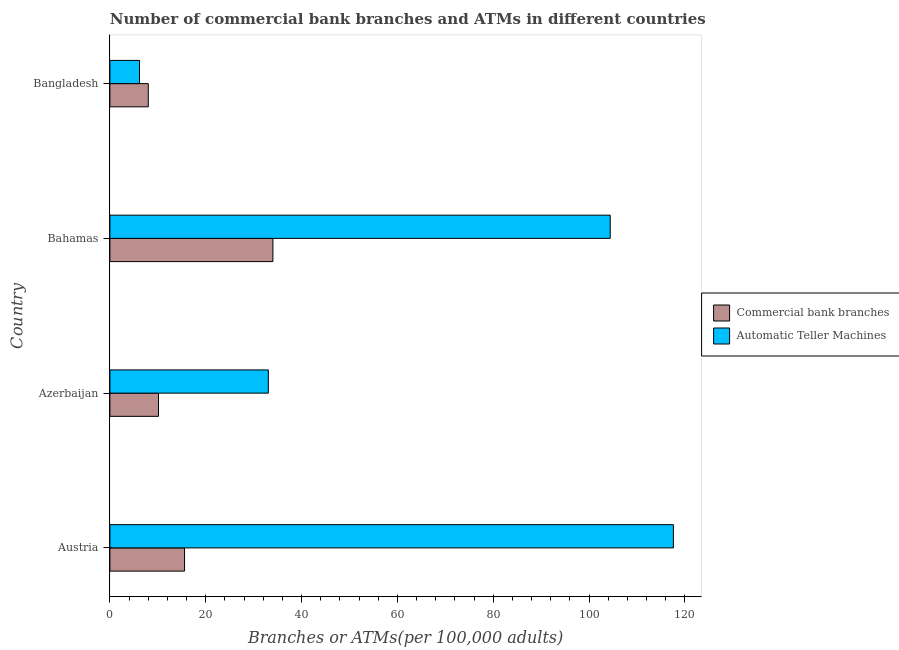How many groups of bars are there?
Offer a very short reply. 4. Are the number of bars per tick equal to the number of legend labels?
Your answer should be very brief. Yes. How many bars are there on the 4th tick from the top?
Keep it short and to the point. 2. How many bars are there on the 3rd tick from the bottom?
Offer a very short reply. 2. What is the label of the 4th group of bars from the top?
Give a very brief answer. Austria. In how many cases, is the number of bars for a given country not equal to the number of legend labels?
Your response must be concise. 0. What is the number of atms in Azerbaijan?
Provide a succinct answer. 33.06. Across all countries, what is the maximum number of commercal bank branches?
Ensure brevity in your answer.  34.02. Across all countries, what is the minimum number of atms?
Your answer should be very brief. 6.18. In which country was the number of atms maximum?
Provide a short and direct response. Austria. In which country was the number of atms minimum?
Your answer should be compact. Bangladesh. What is the total number of atms in the graph?
Your answer should be very brief. 261.26. What is the difference between the number of atms in Bahamas and that in Bangladesh?
Keep it short and to the point. 98.23. What is the difference between the number of commercal bank branches in Austria and the number of atms in Azerbaijan?
Offer a very short reply. -17.48. What is the average number of atms per country?
Your answer should be compact. 65.31. What is the difference between the number of commercal bank branches and number of atms in Bangladesh?
Make the answer very short. 1.83. In how many countries, is the number of atms greater than 4 ?
Provide a short and direct response. 4. What is the ratio of the number of atms in Austria to that in Bahamas?
Keep it short and to the point. 1.13. Is the number of commercal bank branches in Austria less than that in Bahamas?
Your answer should be compact. Yes. What is the difference between the highest and the second highest number of atms?
Your answer should be compact. 13.18. What is the difference between the highest and the lowest number of atms?
Offer a very short reply. 111.42. In how many countries, is the number of atms greater than the average number of atms taken over all countries?
Make the answer very short. 2. Is the sum of the number of atms in Azerbaijan and Bangladesh greater than the maximum number of commercal bank branches across all countries?
Your response must be concise. Yes. What does the 2nd bar from the top in Bangladesh represents?
Provide a short and direct response. Commercial bank branches. What does the 1st bar from the bottom in Austria represents?
Offer a very short reply. Commercial bank branches. Are all the bars in the graph horizontal?
Your response must be concise. Yes. Are the values on the major ticks of X-axis written in scientific E-notation?
Keep it short and to the point. No. Does the graph contain any zero values?
Give a very brief answer. No. Where does the legend appear in the graph?
Make the answer very short. Center right. How are the legend labels stacked?
Give a very brief answer. Vertical. What is the title of the graph?
Offer a very short reply. Number of commercial bank branches and ATMs in different countries. Does "Female labor force" appear as one of the legend labels in the graph?
Keep it short and to the point. No. What is the label or title of the X-axis?
Provide a succinct answer. Branches or ATMs(per 100,0 adults). What is the label or title of the Y-axis?
Your answer should be compact. Country. What is the Branches or ATMs(per 100,000 adults) in Commercial bank branches in Austria?
Provide a short and direct response. 15.58. What is the Branches or ATMs(per 100,000 adults) in Automatic Teller Machines in Austria?
Your answer should be very brief. 117.6. What is the Branches or ATMs(per 100,000 adults) in Commercial bank branches in Azerbaijan?
Provide a short and direct response. 10.14. What is the Branches or ATMs(per 100,000 adults) of Automatic Teller Machines in Azerbaijan?
Ensure brevity in your answer.  33.06. What is the Branches or ATMs(per 100,000 adults) of Commercial bank branches in Bahamas?
Your answer should be compact. 34.02. What is the Branches or ATMs(per 100,000 adults) of Automatic Teller Machines in Bahamas?
Offer a terse response. 104.42. What is the Branches or ATMs(per 100,000 adults) in Commercial bank branches in Bangladesh?
Offer a very short reply. 8.02. What is the Branches or ATMs(per 100,000 adults) in Automatic Teller Machines in Bangladesh?
Give a very brief answer. 6.18. Across all countries, what is the maximum Branches or ATMs(per 100,000 adults) of Commercial bank branches?
Keep it short and to the point. 34.02. Across all countries, what is the maximum Branches or ATMs(per 100,000 adults) in Automatic Teller Machines?
Make the answer very short. 117.6. Across all countries, what is the minimum Branches or ATMs(per 100,000 adults) in Commercial bank branches?
Give a very brief answer. 8.02. Across all countries, what is the minimum Branches or ATMs(per 100,000 adults) of Automatic Teller Machines?
Make the answer very short. 6.18. What is the total Branches or ATMs(per 100,000 adults) of Commercial bank branches in the graph?
Your answer should be compact. 67.76. What is the total Branches or ATMs(per 100,000 adults) in Automatic Teller Machines in the graph?
Your answer should be very brief. 261.26. What is the difference between the Branches or ATMs(per 100,000 adults) in Commercial bank branches in Austria and that in Azerbaijan?
Your answer should be very brief. 5.44. What is the difference between the Branches or ATMs(per 100,000 adults) in Automatic Teller Machines in Austria and that in Azerbaijan?
Your answer should be very brief. 84.53. What is the difference between the Branches or ATMs(per 100,000 adults) of Commercial bank branches in Austria and that in Bahamas?
Provide a short and direct response. -18.44. What is the difference between the Branches or ATMs(per 100,000 adults) in Automatic Teller Machines in Austria and that in Bahamas?
Ensure brevity in your answer.  13.18. What is the difference between the Branches or ATMs(per 100,000 adults) in Commercial bank branches in Austria and that in Bangladesh?
Make the answer very short. 7.57. What is the difference between the Branches or ATMs(per 100,000 adults) of Automatic Teller Machines in Austria and that in Bangladesh?
Your answer should be compact. 111.42. What is the difference between the Branches or ATMs(per 100,000 adults) in Commercial bank branches in Azerbaijan and that in Bahamas?
Offer a very short reply. -23.88. What is the difference between the Branches or ATMs(per 100,000 adults) of Automatic Teller Machines in Azerbaijan and that in Bahamas?
Your answer should be compact. -71.35. What is the difference between the Branches or ATMs(per 100,000 adults) of Commercial bank branches in Azerbaijan and that in Bangladesh?
Your answer should be compact. 2.13. What is the difference between the Branches or ATMs(per 100,000 adults) in Automatic Teller Machines in Azerbaijan and that in Bangladesh?
Make the answer very short. 26.88. What is the difference between the Branches or ATMs(per 100,000 adults) of Commercial bank branches in Bahamas and that in Bangladesh?
Give a very brief answer. 26. What is the difference between the Branches or ATMs(per 100,000 adults) in Automatic Teller Machines in Bahamas and that in Bangladesh?
Make the answer very short. 98.23. What is the difference between the Branches or ATMs(per 100,000 adults) in Commercial bank branches in Austria and the Branches or ATMs(per 100,000 adults) in Automatic Teller Machines in Azerbaijan?
Ensure brevity in your answer.  -17.48. What is the difference between the Branches or ATMs(per 100,000 adults) in Commercial bank branches in Austria and the Branches or ATMs(per 100,000 adults) in Automatic Teller Machines in Bahamas?
Your answer should be compact. -88.83. What is the difference between the Branches or ATMs(per 100,000 adults) of Commercial bank branches in Austria and the Branches or ATMs(per 100,000 adults) of Automatic Teller Machines in Bangladesh?
Provide a short and direct response. 9.4. What is the difference between the Branches or ATMs(per 100,000 adults) of Commercial bank branches in Azerbaijan and the Branches or ATMs(per 100,000 adults) of Automatic Teller Machines in Bahamas?
Your answer should be very brief. -94.27. What is the difference between the Branches or ATMs(per 100,000 adults) of Commercial bank branches in Azerbaijan and the Branches or ATMs(per 100,000 adults) of Automatic Teller Machines in Bangladesh?
Keep it short and to the point. 3.96. What is the difference between the Branches or ATMs(per 100,000 adults) in Commercial bank branches in Bahamas and the Branches or ATMs(per 100,000 adults) in Automatic Teller Machines in Bangladesh?
Provide a succinct answer. 27.84. What is the average Branches or ATMs(per 100,000 adults) of Commercial bank branches per country?
Keep it short and to the point. 16.94. What is the average Branches or ATMs(per 100,000 adults) of Automatic Teller Machines per country?
Your answer should be compact. 65.31. What is the difference between the Branches or ATMs(per 100,000 adults) in Commercial bank branches and Branches or ATMs(per 100,000 adults) in Automatic Teller Machines in Austria?
Your answer should be very brief. -102.01. What is the difference between the Branches or ATMs(per 100,000 adults) of Commercial bank branches and Branches or ATMs(per 100,000 adults) of Automatic Teller Machines in Azerbaijan?
Ensure brevity in your answer.  -22.92. What is the difference between the Branches or ATMs(per 100,000 adults) of Commercial bank branches and Branches or ATMs(per 100,000 adults) of Automatic Teller Machines in Bahamas?
Give a very brief answer. -70.4. What is the difference between the Branches or ATMs(per 100,000 adults) in Commercial bank branches and Branches or ATMs(per 100,000 adults) in Automatic Teller Machines in Bangladesh?
Keep it short and to the point. 1.83. What is the ratio of the Branches or ATMs(per 100,000 adults) of Commercial bank branches in Austria to that in Azerbaijan?
Provide a short and direct response. 1.54. What is the ratio of the Branches or ATMs(per 100,000 adults) of Automatic Teller Machines in Austria to that in Azerbaijan?
Offer a terse response. 3.56. What is the ratio of the Branches or ATMs(per 100,000 adults) of Commercial bank branches in Austria to that in Bahamas?
Your answer should be compact. 0.46. What is the ratio of the Branches or ATMs(per 100,000 adults) in Automatic Teller Machines in Austria to that in Bahamas?
Ensure brevity in your answer.  1.13. What is the ratio of the Branches or ATMs(per 100,000 adults) of Commercial bank branches in Austria to that in Bangladesh?
Ensure brevity in your answer.  1.94. What is the ratio of the Branches or ATMs(per 100,000 adults) in Automatic Teller Machines in Austria to that in Bangladesh?
Your answer should be compact. 19.03. What is the ratio of the Branches or ATMs(per 100,000 adults) in Commercial bank branches in Azerbaijan to that in Bahamas?
Your answer should be very brief. 0.3. What is the ratio of the Branches or ATMs(per 100,000 adults) of Automatic Teller Machines in Azerbaijan to that in Bahamas?
Your response must be concise. 0.32. What is the ratio of the Branches or ATMs(per 100,000 adults) in Commercial bank branches in Azerbaijan to that in Bangladesh?
Keep it short and to the point. 1.27. What is the ratio of the Branches or ATMs(per 100,000 adults) in Automatic Teller Machines in Azerbaijan to that in Bangladesh?
Offer a very short reply. 5.35. What is the ratio of the Branches or ATMs(per 100,000 adults) of Commercial bank branches in Bahamas to that in Bangladesh?
Make the answer very short. 4.24. What is the ratio of the Branches or ATMs(per 100,000 adults) in Automatic Teller Machines in Bahamas to that in Bangladesh?
Keep it short and to the point. 16.89. What is the difference between the highest and the second highest Branches or ATMs(per 100,000 adults) of Commercial bank branches?
Make the answer very short. 18.44. What is the difference between the highest and the second highest Branches or ATMs(per 100,000 adults) in Automatic Teller Machines?
Offer a very short reply. 13.18. What is the difference between the highest and the lowest Branches or ATMs(per 100,000 adults) in Commercial bank branches?
Ensure brevity in your answer.  26. What is the difference between the highest and the lowest Branches or ATMs(per 100,000 adults) of Automatic Teller Machines?
Your answer should be very brief. 111.42. 